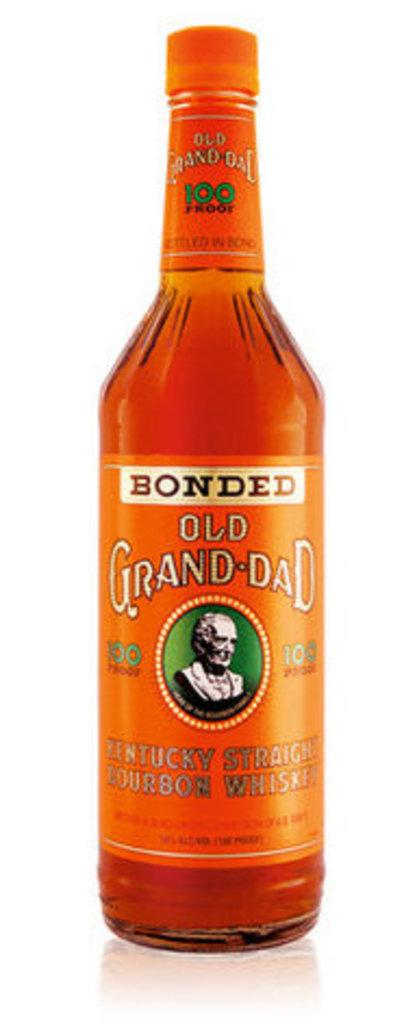<image>
Create a compact narrative representing the image presented. A bottle of Bonded Old Grand-Dad has a picture of a statue bust on it. 